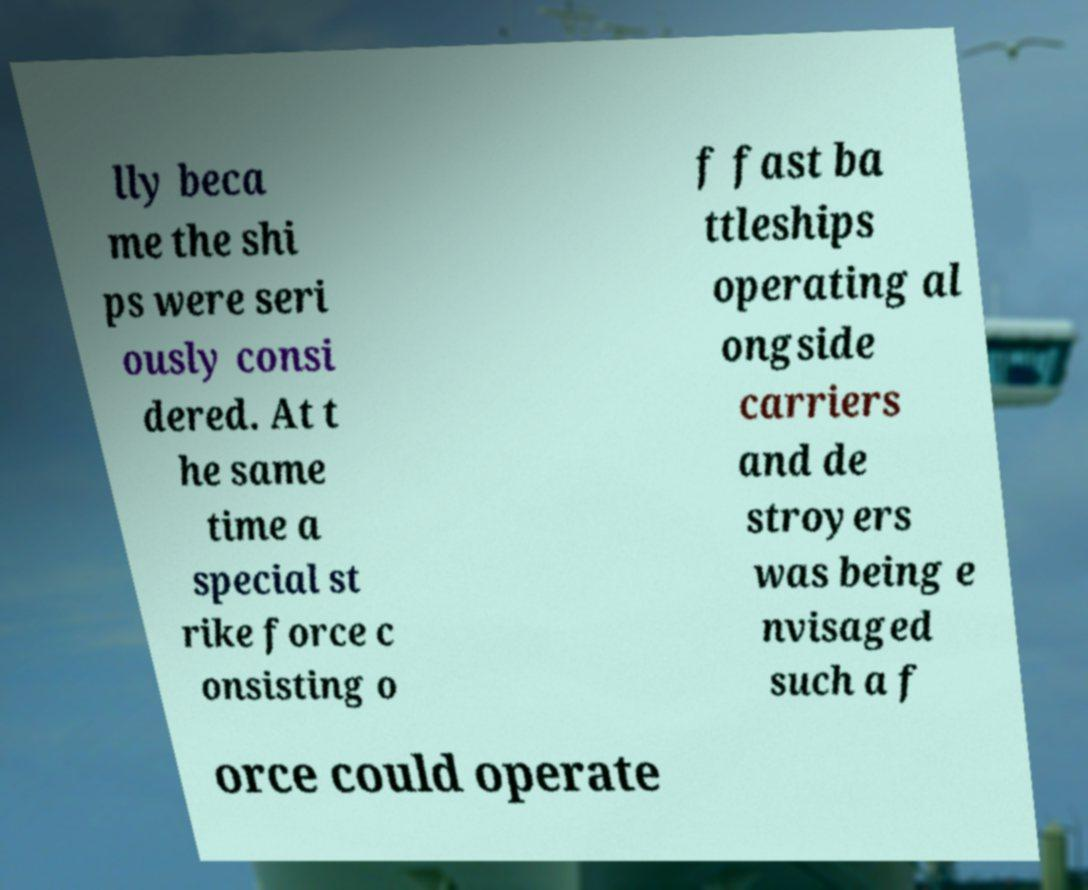Could you assist in decoding the text presented in this image and type it out clearly? lly beca me the shi ps were seri ously consi dered. At t he same time a special st rike force c onsisting o f fast ba ttleships operating al ongside carriers and de stroyers was being e nvisaged such a f orce could operate 